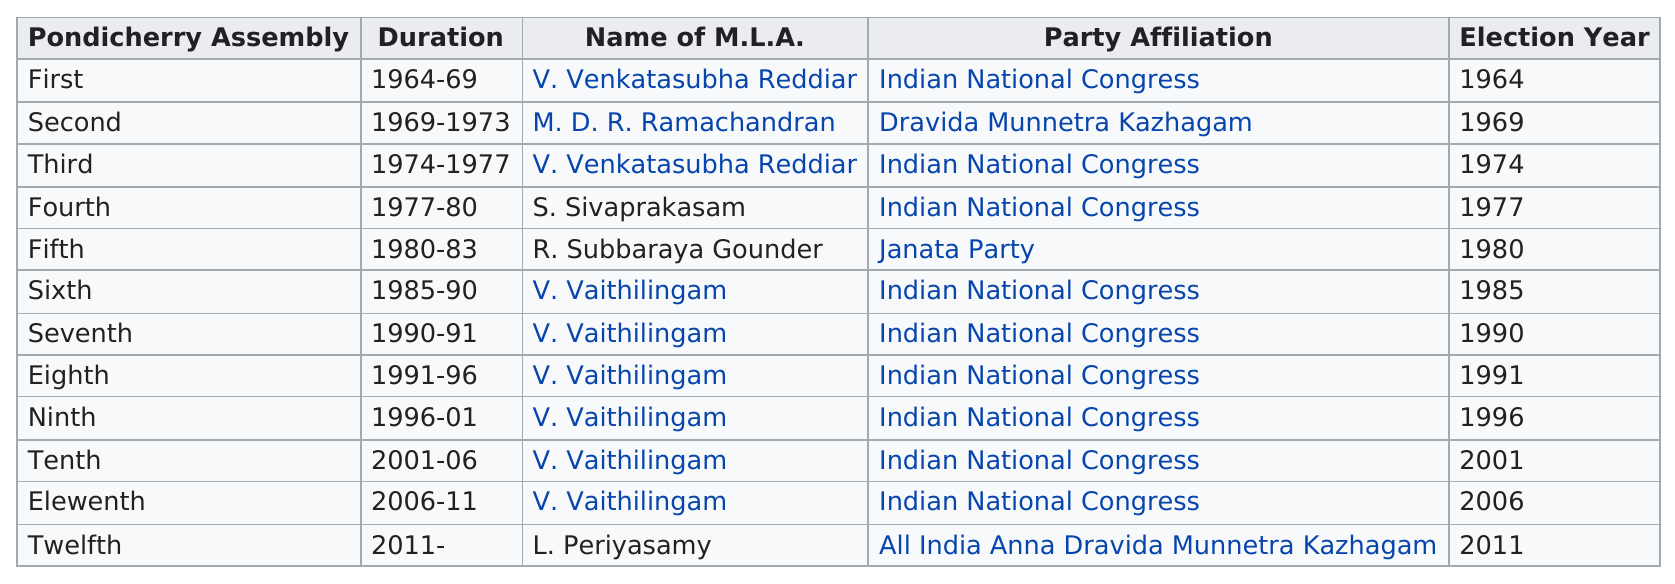Point out several critical features in this image. Vaithilingam was served by L. Periyasamy after him. In an election year, the difference in years between the first and second members on the list is five. The first election was held in 1964. R. Subbaraya Gounder was elected after S. Sivaprakasam in the fifth Pondicherry Assembly. There have been 12 assemblies in total. 